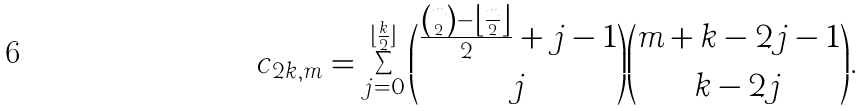<formula> <loc_0><loc_0><loc_500><loc_500>c _ { 2 k , m } = \sum _ { j = 0 } ^ { \lfloor \frac { k } { 2 } \rfloor } { \frac { { m \choose 2 } - \left \lfloor \frac { m } { 2 } \right \rfloor } { 2 } + j - 1 \choose j } { m + k - 2 j - 1 \choose k - 2 j } .</formula> 